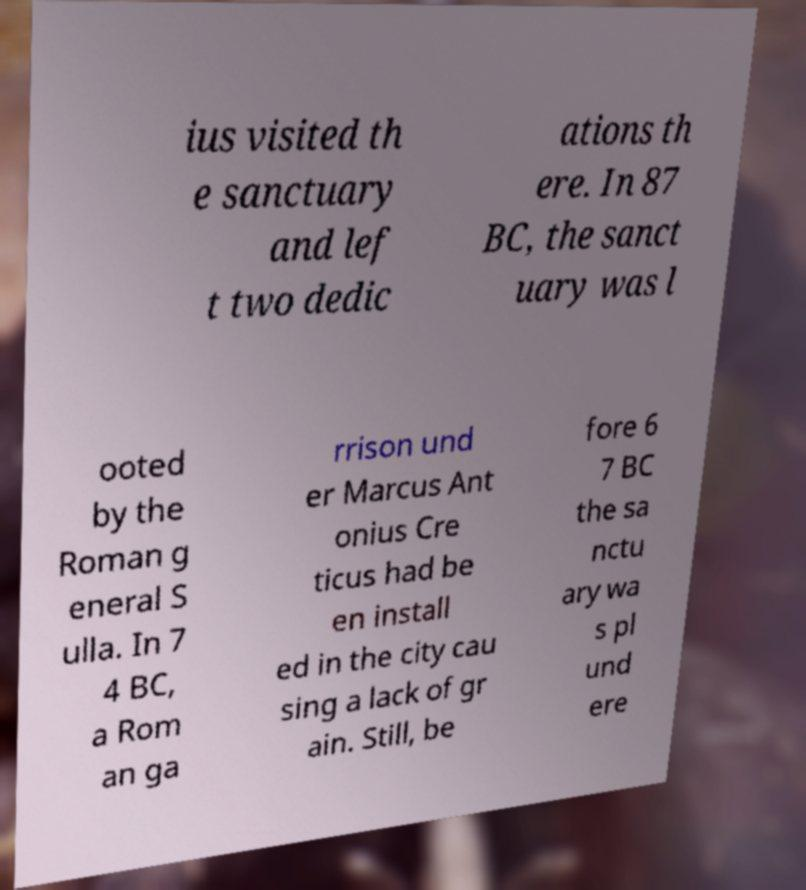Could you assist in decoding the text presented in this image and type it out clearly? ius visited th e sanctuary and lef t two dedic ations th ere. In 87 BC, the sanct uary was l ooted by the Roman g eneral S ulla. In 7 4 BC, a Rom an ga rrison und er Marcus Ant onius Cre ticus had be en install ed in the city cau sing a lack of gr ain. Still, be fore 6 7 BC the sa nctu ary wa s pl und ere 